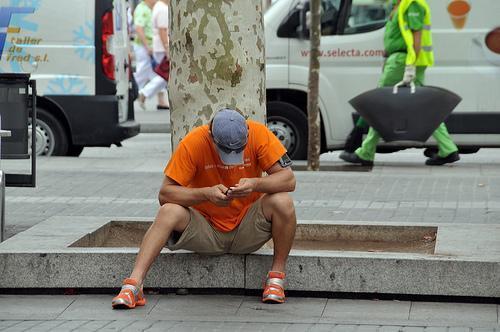How many trucks are in the background?
Give a very brief answer. 2. How many people are wearing hats?
Give a very brief answer. 1. How many trucks are there?
Give a very brief answer. 2. How many people are there?
Give a very brief answer. 3. 